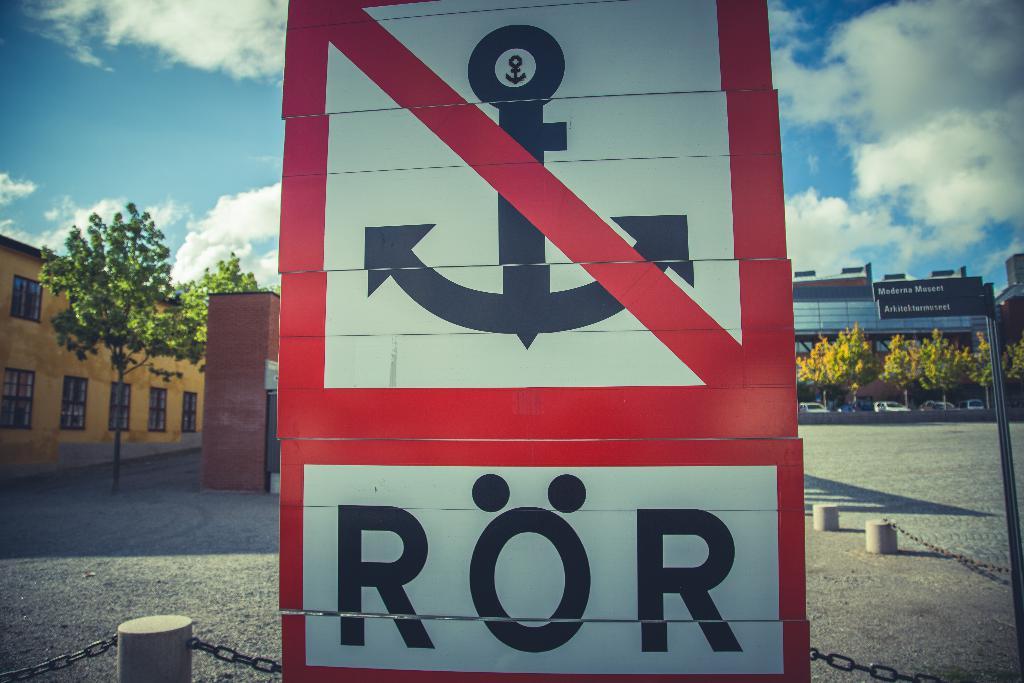What slogan is at the bottom of the sign under the anchor?
Give a very brief answer. Ror. 